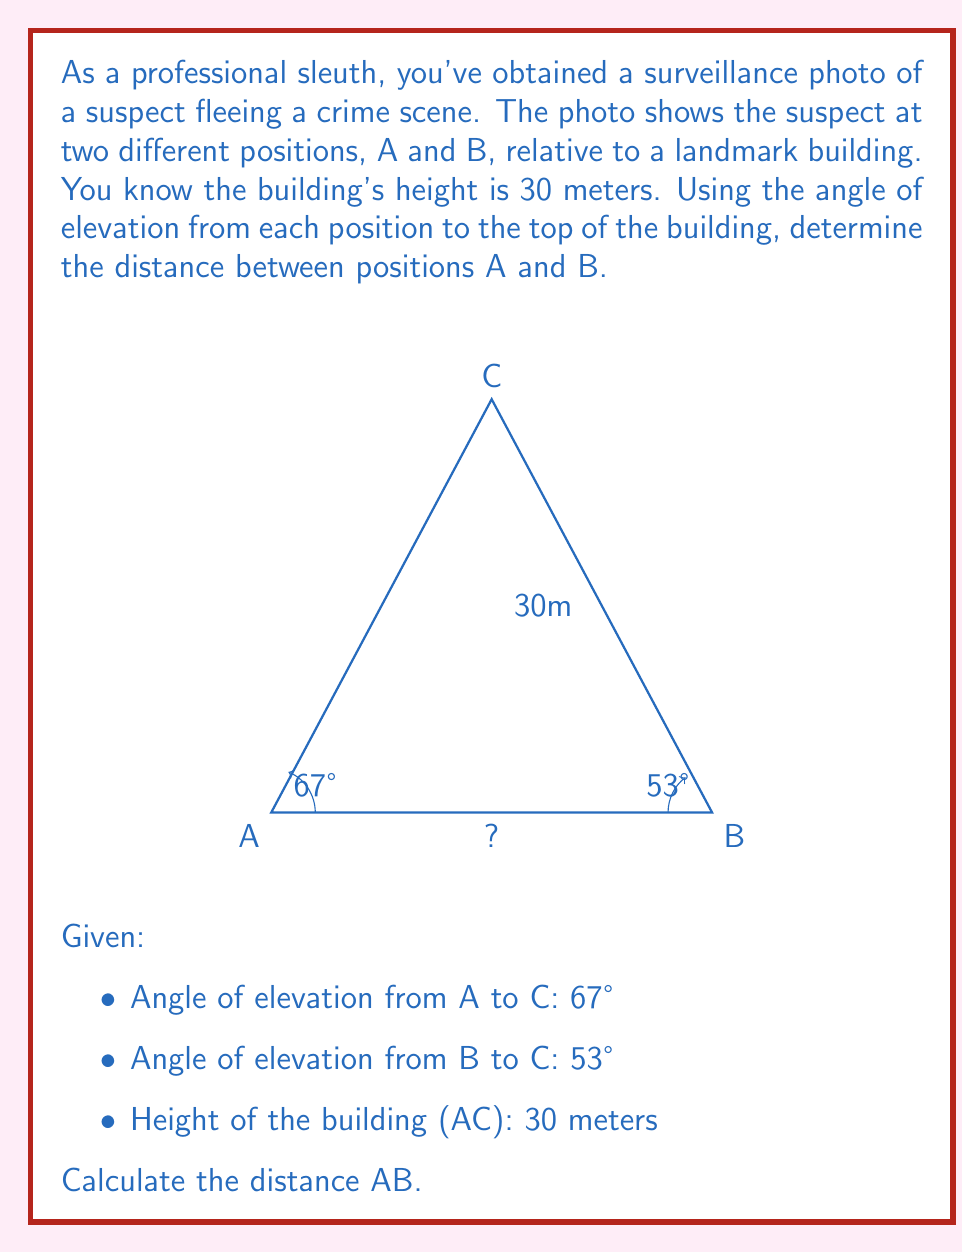What is the answer to this math problem? Let's solve this step-by-step using trigonometry:

1) First, let's consider the right triangle ACX, where X is the point directly below C on the ground.
   $\tan(67°) = \frac{AC}{AX} = \frac{30}{AX}$
   $AX = \frac{30}{\tan(67°)} \approx 13.22$ meters

2) Similarly, for triangle BCX:
   $\tan(53°) = \frac{BC}{BX} = \frac{30}{BX}$
   $BX = \frac{30}{\tan(53°)} \approx 22.56$ meters

3) The distance AB is the difference between BX and AX:
   $AB = BX - AX = 22.56 - 13.22 \approx 9.34$ meters

4) To verify, we can use the Pythagorean theorem:
   $AC^2 = AX^2 + 30^2$ and $AC^2 = BX^2 + 30^2$
   Therefore, $AX^2 + 30^2 = BX^2 + 30^2$
   $AX^2 = BX^2$
   $BX = \sqrt{AX^2 + AB^2}$
   $22.56 \approx \sqrt{13.22^2 + 9.34^2}$

This confirms our calculation.
Answer: $9.34$ meters 